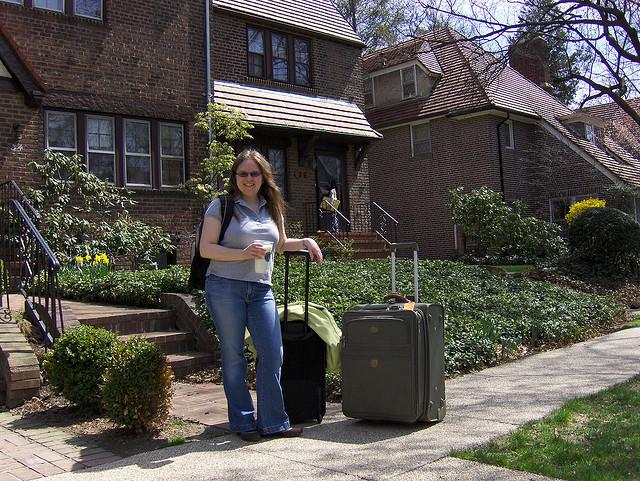What food and beverage purveyor did this woman visit most recently?

Choices:
A) starbucks
B) burger king
C) taco bell
D) mcdonalds starbucks 